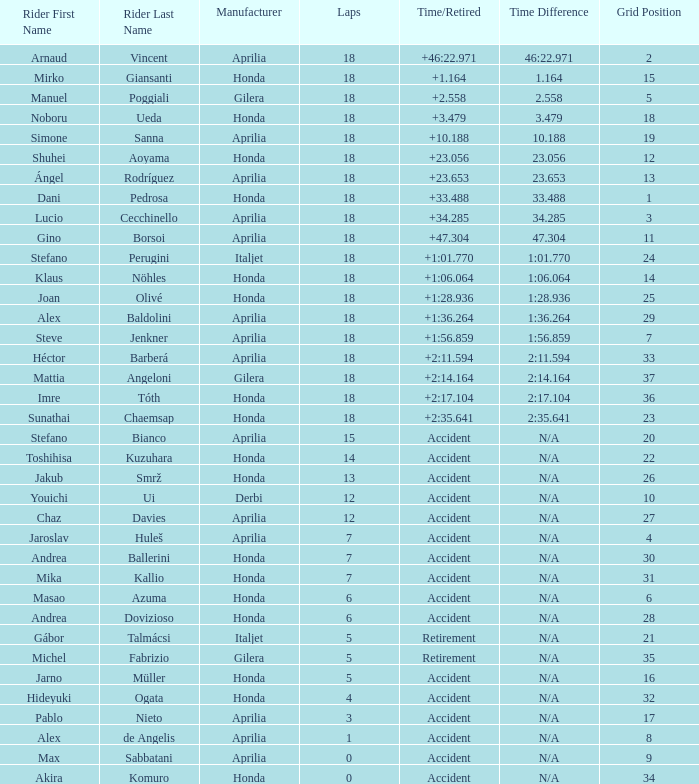What is the time/retired for the honda manufacturer with a grid lesser than 26, 18 laps, and joan olivé as the pilot? +1:28.936. 